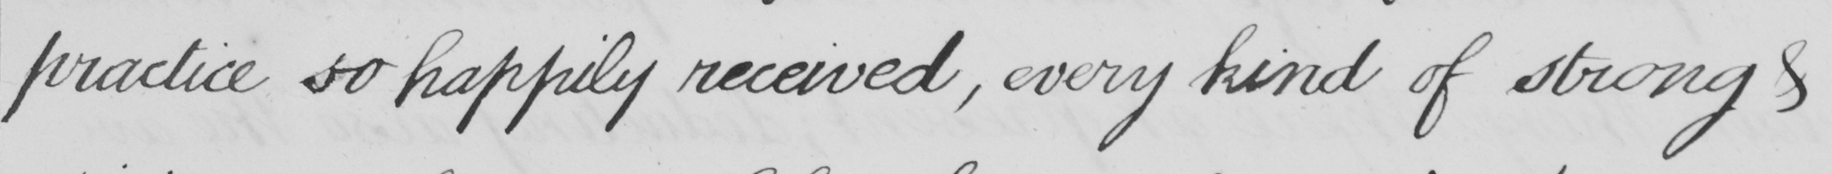What is written in this line of handwriting? practice so happily received, every kind of strong & 